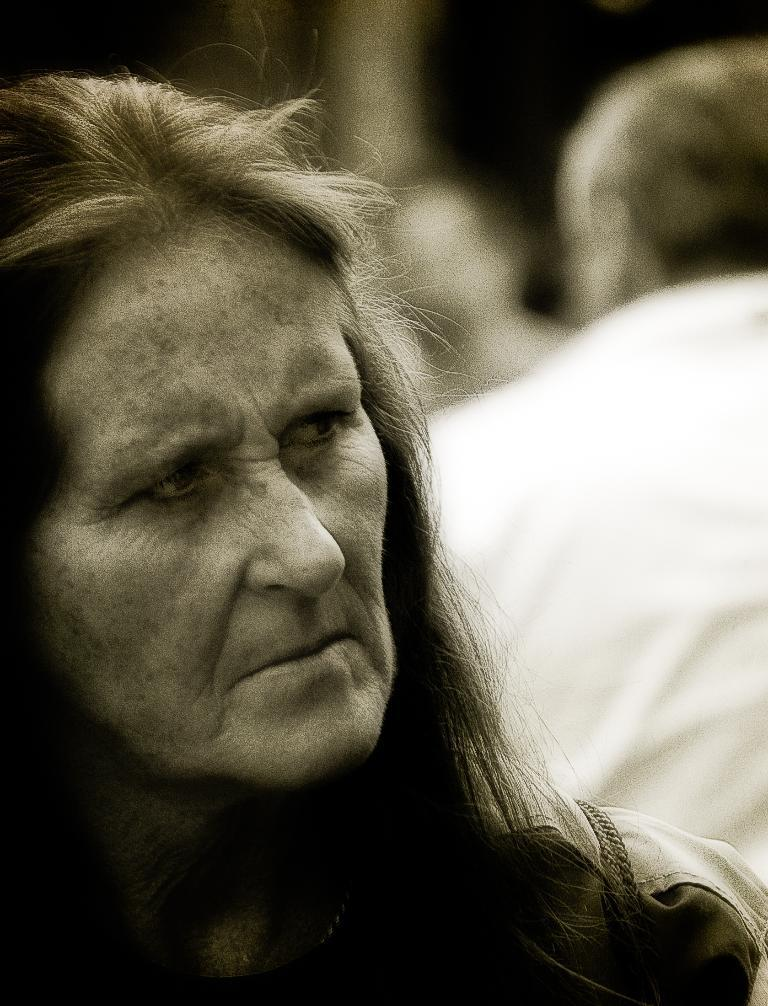What is the color scheme of the image? The image is black and white. Can you describe the people in the image? There is a woman and a man in the image. How is the man positioned in relation to the woman? The man is positioned on the backside in the image. What type of wing can be seen on the goose in the image? There is no goose or wing present in the image; it features a woman and a man. What kind of rhythm is the couple dancing to in the image? The image does not depict dancing, so it is not possible to determine the rhythm. 